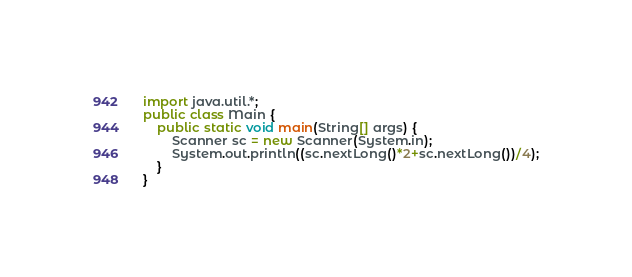Convert code to text. <code><loc_0><loc_0><loc_500><loc_500><_Java_>import java.util.*;
public class Main {
    public static void main(String[] args) {
        Scanner sc = new Scanner(System.in);
        System.out.println((sc.nextLong()*2+sc.nextLong())/4);
    }
}</code> 